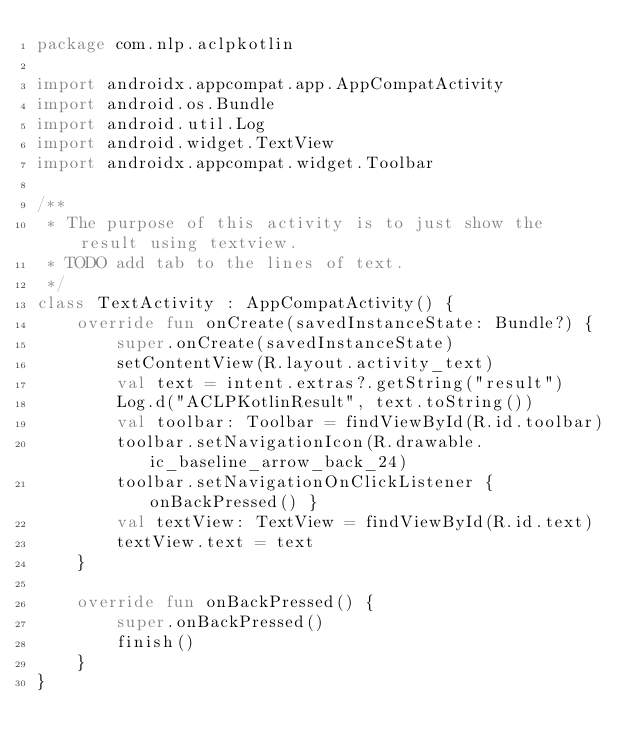<code> <loc_0><loc_0><loc_500><loc_500><_Kotlin_>package com.nlp.aclpkotlin

import androidx.appcompat.app.AppCompatActivity
import android.os.Bundle
import android.util.Log
import android.widget.TextView
import androidx.appcompat.widget.Toolbar

/**
 * The purpose of this activity is to just show the result using textview.
 * TODO add tab to the lines of text.
 */
class TextActivity : AppCompatActivity() {
    override fun onCreate(savedInstanceState: Bundle?) {
        super.onCreate(savedInstanceState)
        setContentView(R.layout.activity_text)
        val text = intent.extras?.getString("result")
        Log.d("ACLPKotlinResult", text.toString())
        val toolbar: Toolbar = findViewById(R.id.toolbar)
        toolbar.setNavigationIcon(R.drawable.ic_baseline_arrow_back_24)
        toolbar.setNavigationOnClickListener { onBackPressed() }
        val textView: TextView = findViewById(R.id.text)
        textView.text = text
    }

    override fun onBackPressed() {
        super.onBackPressed()
        finish()
    }
}</code> 